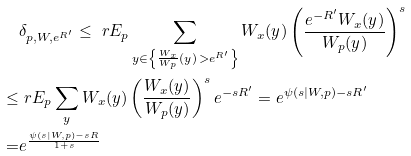<formula> <loc_0><loc_0><loc_500><loc_500>& \delta _ { p , W , e ^ { R ^ { \prime } } } \leq \ r E _ { p } \sum _ { y \in \left \{ \frac { W _ { x } } { W _ { p } } ( y ) \, > e ^ { R ^ { \prime } } \right \} } W _ { x } ( y ) \left ( \frac { e ^ { - R ^ { \prime } } W _ { x } ( y ) } { W _ { p } ( y ) } \right ) ^ { s } \\ \leq & \ r E _ { p } \sum _ { y } W _ { x } ( y ) \left ( \frac { W _ { x } ( y ) } { W _ { p } ( y ) } \right ) ^ { s } e ^ { - s R ^ { \prime } } = e ^ { \psi ( s | W , p ) - s R ^ { \prime } } \\ = & e ^ { \frac { \psi ( s | W , p ) - s R } { 1 + s } }</formula> 